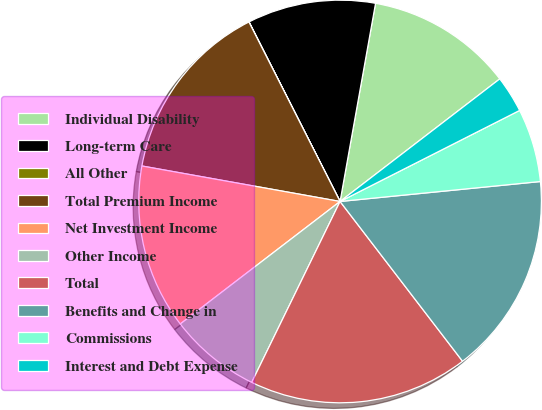Convert chart to OTSL. <chart><loc_0><loc_0><loc_500><loc_500><pie_chart><fcel>Individual Disability<fcel>Long-term Care<fcel>All Other<fcel>Total Premium Income<fcel>Net Investment Income<fcel>Other Income<fcel>Total<fcel>Benefits and Change in<fcel>Commissions<fcel>Interest and Debt Expense<nl><fcel>11.76%<fcel>10.29%<fcel>0.01%<fcel>14.7%<fcel>13.23%<fcel>7.36%<fcel>17.64%<fcel>16.17%<fcel>5.89%<fcel>2.95%<nl></chart> 